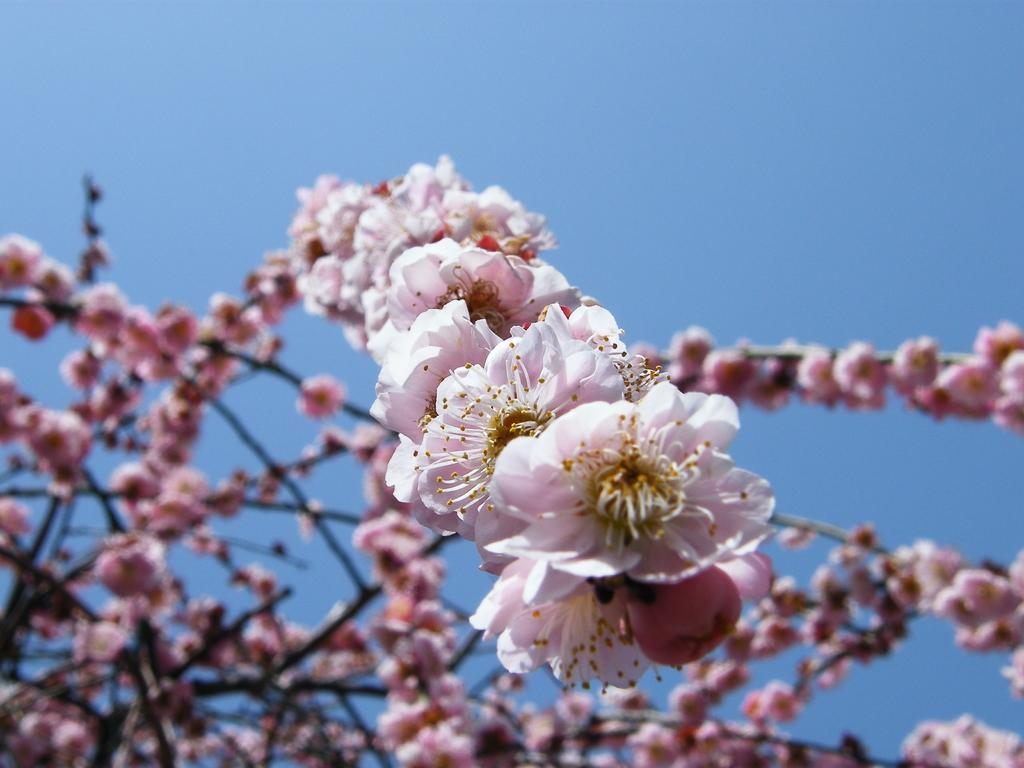What type of plant can be seen in the image? There is a tree in the image. What color is the flower that is visible in the image? There is a pink-colored flower in the image. What part of the natural environment is visible in the image? The sky is visible in the image. What type of knee support is visible in the image? There is no knee support present in the image. What type of hydrant can be seen in the image? There is no hydrant present in the image. 